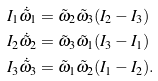<formula> <loc_0><loc_0><loc_500><loc_500>I _ { 1 } \dot { \tilde { \omega } } _ { 1 } & = \tilde { \omega } _ { 2 } \tilde { \omega } _ { 3 } ( I _ { 2 } - I _ { 3 } ) \\ I _ { 2 } \dot { \tilde { \omega } } _ { 2 } & = \tilde { \omega } _ { 3 } \tilde { \omega } _ { 1 } ( I _ { 3 } - I _ { 1 } ) \\ I _ { 3 } \dot { \tilde { \omega } } _ { 3 } & = \tilde { \omega } _ { 1 } \tilde { \omega } _ { 2 } ( I _ { 1 } - I _ { 2 } ) .</formula> 